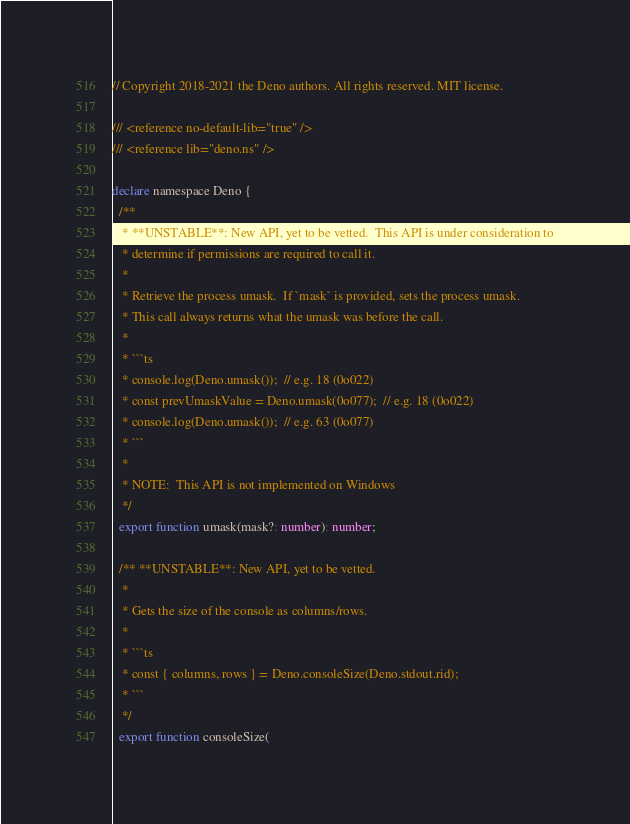<code> <loc_0><loc_0><loc_500><loc_500><_TypeScript_>// Copyright 2018-2021 the Deno authors. All rights reserved. MIT license.

/// <reference no-default-lib="true" />
/// <reference lib="deno.ns" />

declare namespace Deno {
  /**
   * **UNSTABLE**: New API, yet to be vetted.  This API is under consideration to
   * determine if permissions are required to call it.
   *
   * Retrieve the process umask.  If `mask` is provided, sets the process umask.
   * This call always returns what the umask was before the call.
   *
   * ```ts
   * console.log(Deno.umask());  // e.g. 18 (0o022)
   * const prevUmaskValue = Deno.umask(0o077);  // e.g. 18 (0o022)
   * console.log(Deno.umask());  // e.g. 63 (0o077)
   * ```
   *
   * NOTE:  This API is not implemented on Windows
   */
  export function umask(mask?: number): number;

  /** **UNSTABLE**: New API, yet to be vetted.
   *
   * Gets the size of the console as columns/rows.
   *
   * ```ts
   * const { columns, rows } = Deno.consoleSize(Deno.stdout.rid);
   * ```
   */
  export function consoleSize(</code> 